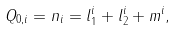<formula> <loc_0><loc_0><loc_500><loc_500>Q _ { 0 , i } = n _ { i } = l _ { 1 } ^ { i } + l _ { 2 } ^ { i } + m ^ { i } ,</formula> 